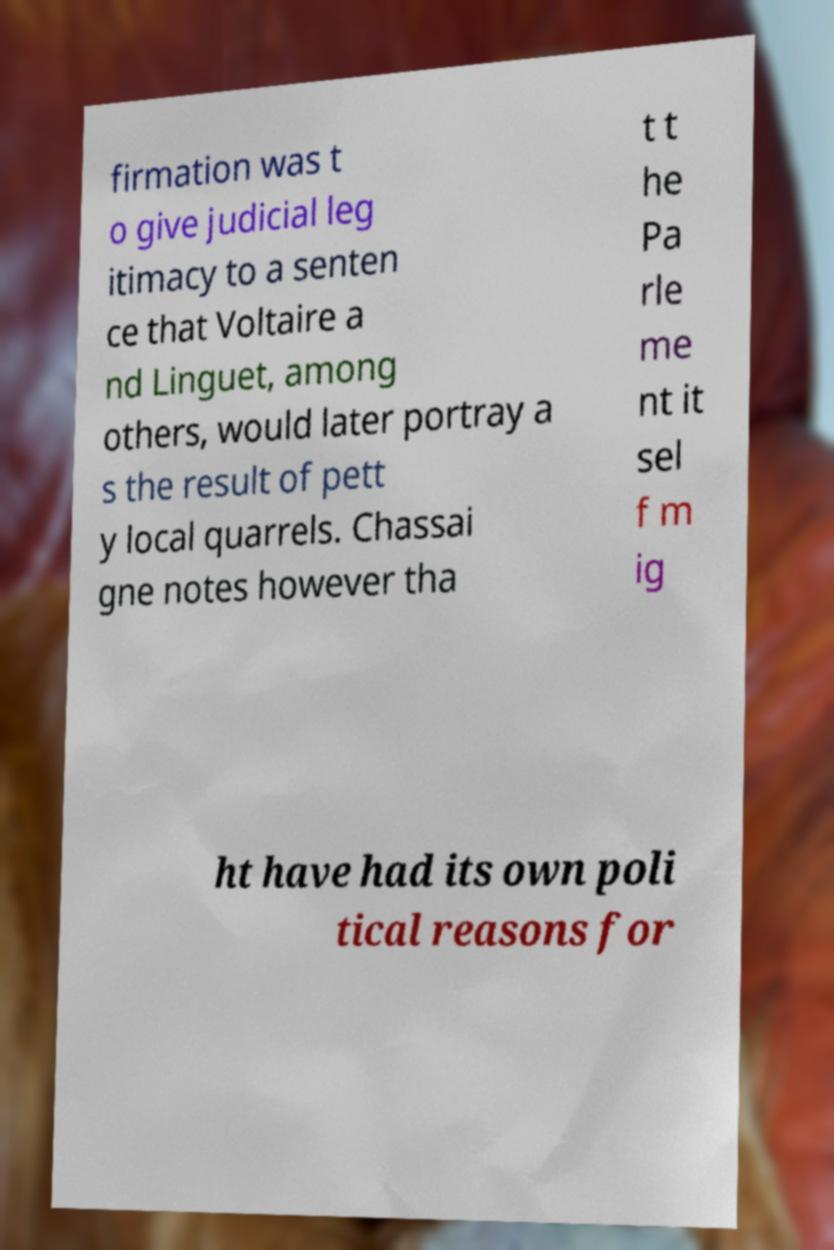Please identify and transcribe the text found in this image. firmation was t o give judicial leg itimacy to a senten ce that Voltaire a nd Linguet, among others, would later portray a s the result of pett y local quarrels. Chassai gne notes however tha t t he Pa rle me nt it sel f m ig ht have had its own poli tical reasons for 